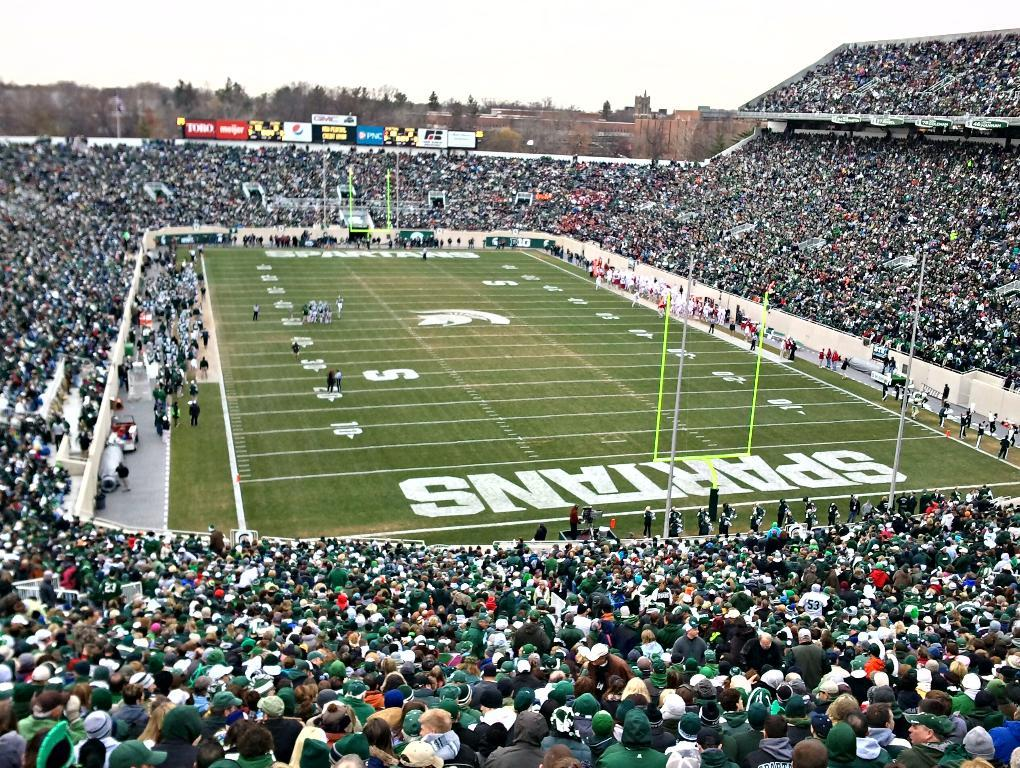Provide a one-sentence caption for the provided image. The stadium of the Spartans was sold out for the football game. 